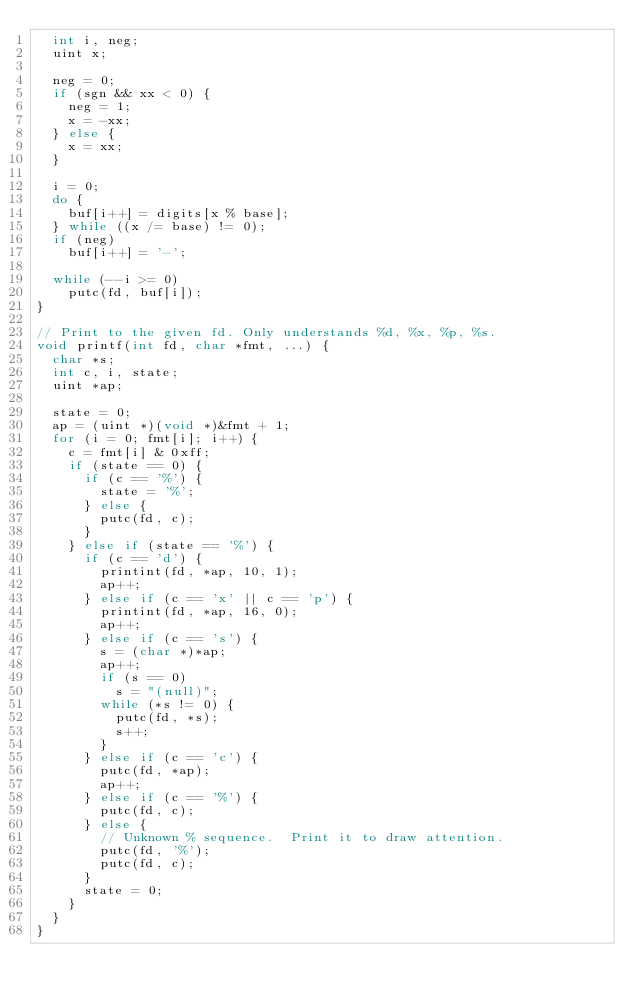<code> <loc_0><loc_0><loc_500><loc_500><_C_>  int i, neg;
  uint x;

  neg = 0;
  if (sgn && xx < 0) {
    neg = 1;
    x = -xx;
  } else {
    x = xx;
  }

  i = 0;
  do {
    buf[i++] = digits[x % base];
  } while ((x /= base) != 0);
  if (neg)
    buf[i++] = '-';

  while (--i >= 0)
    putc(fd, buf[i]);
}

// Print to the given fd. Only understands %d, %x, %p, %s.
void printf(int fd, char *fmt, ...) {
  char *s;
  int c, i, state;
  uint *ap;

  state = 0;
  ap = (uint *)(void *)&fmt + 1;
  for (i = 0; fmt[i]; i++) {
    c = fmt[i] & 0xff;
    if (state == 0) {
      if (c == '%') {
        state = '%';
      } else {
        putc(fd, c);
      }
    } else if (state == '%') {
      if (c == 'd') {
        printint(fd, *ap, 10, 1);
        ap++;
      } else if (c == 'x' || c == 'p') {
        printint(fd, *ap, 16, 0);
        ap++;
      } else if (c == 's') {
        s = (char *)*ap;
        ap++;
        if (s == 0)
          s = "(null)";
        while (*s != 0) {
          putc(fd, *s);
          s++;
        }
      } else if (c == 'c') {
        putc(fd, *ap);
        ap++;
      } else if (c == '%') {
        putc(fd, c);
      } else {
        // Unknown % sequence.  Print it to draw attention.
        putc(fd, '%');
        putc(fd, c);
      }
      state = 0;
    }
  }
}
</code> 